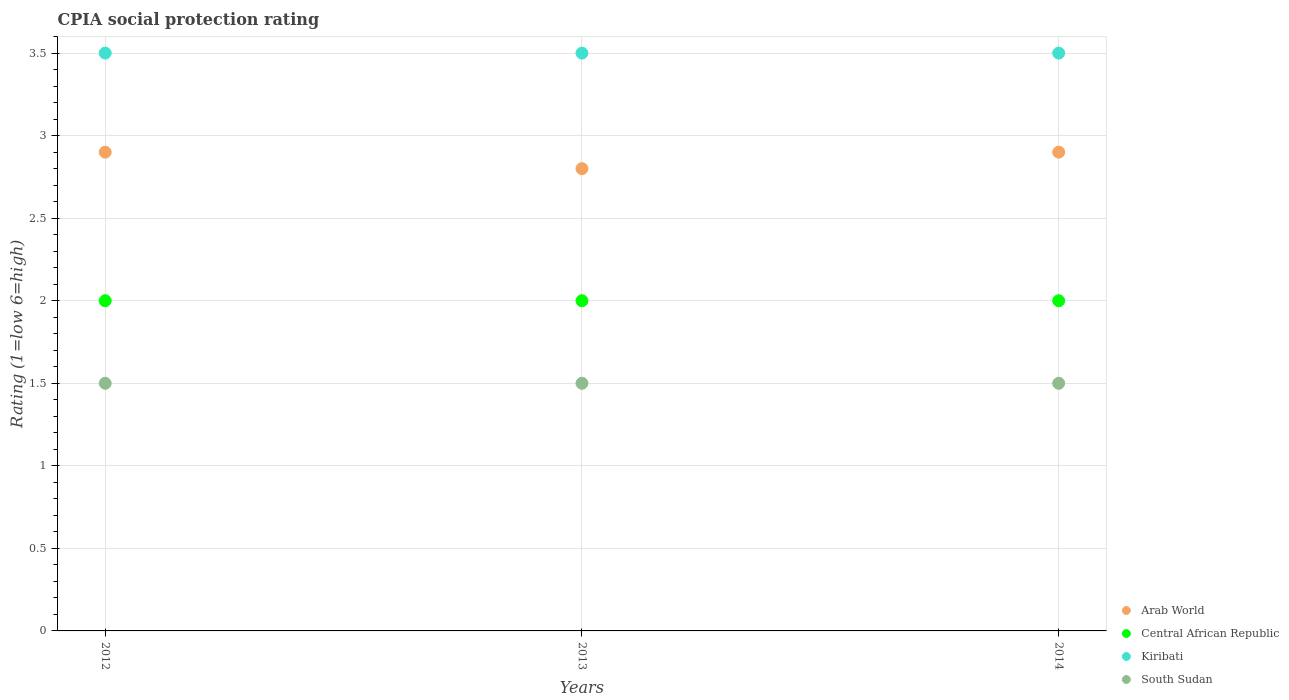Is the number of dotlines equal to the number of legend labels?
Offer a very short reply. Yes. What is the CPIA rating in Central African Republic in 2012?
Offer a terse response. 2. Across all years, what is the maximum CPIA rating in Central African Republic?
Your answer should be compact. 2. In which year was the CPIA rating in Kiribati minimum?
Your response must be concise. 2012. What is the difference between the CPIA rating in Central African Republic in 2012 and that in 2013?
Keep it short and to the point. 0. What is the difference between the CPIA rating in South Sudan in 2013 and the CPIA rating in Arab World in 2014?
Offer a very short reply. -1.4. What is the average CPIA rating in South Sudan per year?
Give a very brief answer. 1.5. In the year 2014, what is the difference between the CPIA rating in Arab World and CPIA rating in Central African Republic?
Give a very brief answer. 0.9. What is the ratio of the CPIA rating in Arab World in 2013 to that in 2014?
Your answer should be compact. 0.97. Is the difference between the CPIA rating in Arab World in 2013 and 2014 greater than the difference between the CPIA rating in Central African Republic in 2013 and 2014?
Offer a very short reply. No. What is the difference between the highest and the lowest CPIA rating in Kiribati?
Make the answer very short. 0. In how many years, is the CPIA rating in South Sudan greater than the average CPIA rating in South Sudan taken over all years?
Give a very brief answer. 0. Does the CPIA rating in Arab World monotonically increase over the years?
Ensure brevity in your answer.  No. Is the CPIA rating in South Sudan strictly greater than the CPIA rating in Arab World over the years?
Your answer should be compact. No. Is the CPIA rating in Central African Republic strictly less than the CPIA rating in Arab World over the years?
Give a very brief answer. Yes. How many dotlines are there?
Provide a short and direct response. 4. How many years are there in the graph?
Your answer should be very brief. 3. Are the values on the major ticks of Y-axis written in scientific E-notation?
Provide a succinct answer. No. Does the graph contain any zero values?
Keep it short and to the point. No. Does the graph contain grids?
Your answer should be very brief. Yes. How many legend labels are there?
Keep it short and to the point. 4. What is the title of the graph?
Your answer should be compact. CPIA social protection rating. Does "Least developed countries" appear as one of the legend labels in the graph?
Your response must be concise. No. What is the Rating (1=low 6=high) in Arab World in 2012?
Provide a short and direct response. 2.9. What is the Rating (1=low 6=high) of Arab World in 2013?
Your answer should be very brief. 2.8. What is the Rating (1=low 6=high) of Central African Republic in 2013?
Provide a short and direct response. 2. What is the Rating (1=low 6=high) of Central African Republic in 2014?
Provide a succinct answer. 2. What is the Rating (1=low 6=high) of Kiribati in 2014?
Offer a very short reply. 3.5. Across all years, what is the maximum Rating (1=low 6=high) in Kiribati?
Provide a short and direct response. 3.5. Across all years, what is the minimum Rating (1=low 6=high) of South Sudan?
Your answer should be compact. 1.5. What is the total Rating (1=low 6=high) in Kiribati in the graph?
Make the answer very short. 10.5. What is the total Rating (1=low 6=high) of South Sudan in the graph?
Offer a very short reply. 4.5. What is the difference between the Rating (1=low 6=high) in Arab World in 2012 and that in 2013?
Ensure brevity in your answer.  0.1. What is the difference between the Rating (1=low 6=high) of South Sudan in 2012 and that in 2013?
Ensure brevity in your answer.  0. What is the difference between the Rating (1=low 6=high) in Central African Republic in 2012 and that in 2014?
Make the answer very short. 0. What is the difference between the Rating (1=low 6=high) of Kiribati in 2013 and that in 2014?
Your answer should be compact. 0. What is the difference between the Rating (1=low 6=high) in South Sudan in 2013 and that in 2014?
Keep it short and to the point. 0. What is the difference between the Rating (1=low 6=high) in Arab World in 2012 and the Rating (1=low 6=high) in Central African Republic in 2013?
Ensure brevity in your answer.  0.9. What is the difference between the Rating (1=low 6=high) of Arab World in 2012 and the Rating (1=low 6=high) of Kiribati in 2013?
Offer a terse response. -0.6. What is the difference between the Rating (1=low 6=high) in Kiribati in 2012 and the Rating (1=low 6=high) in South Sudan in 2013?
Provide a short and direct response. 2. What is the difference between the Rating (1=low 6=high) in Arab World in 2012 and the Rating (1=low 6=high) in Central African Republic in 2014?
Ensure brevity in your answer.  0.9. What is the difference between the Rating (1=low 6=high) in Arab World in 2012 and the Rating (1=low 6=high) in Kiribati in 2014?
Keep it short and to the point. -0.6. What is the difference between the Rating (1=low 6=high) in Arab World in 2013 and the Rating (1=low 6=high) in Kiribati in 2014?
Keep it short and to the point. -0.7. What is the difference between the Rating (1=low 6=high) in Kiribati in 2013 and the Rating (1=low 6=high) in South Sudan in 2014?
Your response must be concise. 2. What is the average Rating (1=low 6=high) of Arab World per year?
Provide a short and direct response. 2.87. What is the average Rating (1=low 6=high) in Central African Republic per year?
Keep it short and to the point. 2. In the year 2012, what is the difference between the Rating (1=low 6=high) in Arab World and Rating (1=low 6=high) in South Sudan?
Make the answer very short. 1.4. In the year 2012, what is the difference between the Rating (1=low 6=high) in Central African Republic and Rating (1=low 6=high) in Kiribati?
Provide a succinct answer. -1.5. In the year 2012, what is the difference between the Rating (1=low 6=high) of Central African Republic and Rating (1=low 6=high) of South Sudan?
Ensure brevity in your answer.  0.5. In the year 2013, what is the difference between the Rating (1=low 6=high) of Arab World and Rating (1=low 6=high) of South Sudan?
Provide a succinct answer. 1.3. In the year 2013, what is the difference between the Rating (1=low 6=high) in Kiribati and Rating (1=low 6=high) in South Sudan?
Your answer should be very brief. 2. In the year 2014, what is the difference between the Rating (1=low 6=high) of Arab World and Rating (1=low 6=high) of Kiribati?
Ensure brevity in your answer.  -0.6. In the year 2014, what is the difference between the Rating (1=low 6=high) of Arab World and Rating (1=low 6=high) of South Sudan?
Your answer should be compact. 1.4. In the year 2014, what is the difference between the Rating (1=low 6=high) of Central African Republic and Rating (1=low 6=high) of South Sudan?
Offer a terse response. 0.5. In the year 2014, what is the difference between the Rating (1=low 6=high) in Kiribati and Rating (1=low 6=high) in South Sudan?
Provide a succinct answer. 2. What is the ratio of the Rating (1=low 6=high) in Arab World in 2012 to that in 2013?
Provide a succinct answer. 1.04. What is the ratio of the Rating (1=low 6=high) of Kiribati in 2012 to that in 2013?
Your answer should be compact. 1. What is the ratio of the Rating (1=low 6=high) in Kiribati in 2012 to that in 2014?
Provide a succinct answer. 1. What is the ratio of the Rating (1=low 6=high) in Arab World in 2013 to that in 2014?
Provide a succinct answer. 0.97. What is the ratio of the Rating (1=low 6=high) of Central African Republic in 2013 to that in 2014?
Offer a terse response. 1. What is the ratio of the Rating (1=low 6=high) in Kiribati in 2013 to that in 2014?
Your answer should be very brief. 1. What is the difference between the highest and the second highest Rating (1=low 6=high) of Central African Republic?
Provide a short and direct response. 0. What is the difference between the highest and the lowest Rating (1=low 6=high) in Arab World?
Your response must be concise. 0.1. What is the difference between the highest and the lowest Rating (1=low 6=high) of Central African Republic?
Provide a succinct answer. 0. What is the difference between the highest and the lowest Rating (1=low 6=high) in Kiribati?
Keep it short and to the point. 0. What is the difference between the highest and the lowest Rating (1=low 6=high) of South Sudan?
Provide a succinct answer. 0. 